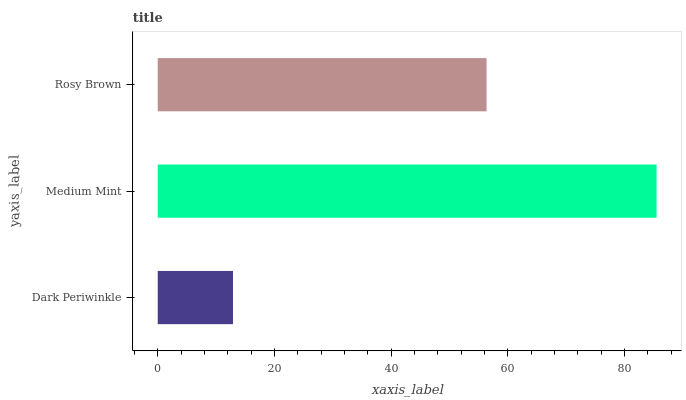Is Dark Periwinkle the minimum?
Answer yes or no. Yes. Is Medium Mint the maximum?
Answer yes or no. Yes. Is Rosy Brown the minimum?
Answer yes or no. No. Is Rosy Brown the maximum?
Answer yes or no. No. Is Medium Mint greater than Rosy Brown?
Answer yes or no. Yes. Is Rosy Brown less than Medium Mint?
Answer yes or no. Yes. Is Rosy Brown greater than Medium Mint?
Answer yes or no. No. Is Medium Mint less than Rosy Brown?
Answer yes or no. No. Is Rosy Brown the high median?
Answer yes or no. Yes. Is Rosy Brown the low median?
Answer yes or no. Yes. Is Medium Mint the high median?
Answer yes or no. No. Is Dark Periwinkle the low median?
Answer yes or no. No. 